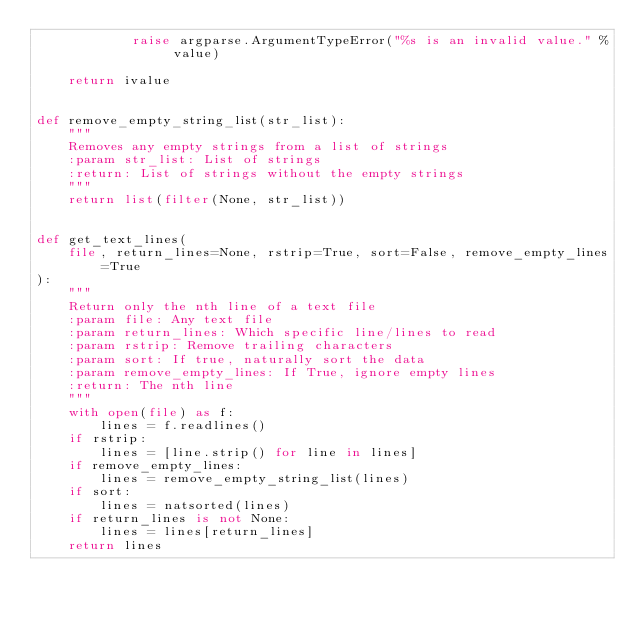<code> <loc_0><loc_0><loc_500><loc_500><_Python_>            raise argparse.ArgumentTypeError("%s is an invalid value." % value)

    return ivalue


def remove_empty_string_list(str_list):
    """
    Removes any empty strings from a list of strings
    :param str_list: List of strings
    :return: List of strings without the empty strings
    """
    return list(filter(None, str_list))


def get_text_lines(
    file, return_lines=None, rstrip=True, sort=False, remove_empty_lines=True
):
    """
    Return only the nth line of a text file
    :param file: Any text file
    :param return_lines: Which specific line/lines to read
    :param rstrip: Remove trailing characters
    :param sort: If true, naturally sort the data
    :param remove_empty_lines: If True, ignore empty lines
    :return: The nth line
    """
    with open(file) as f:
        lines = f.readlines()
    if rstrip:
        lines = [line.strip() for line in lines]
    if remove_empty_lines:
        lines = remove_empty_string_list(lines)
    if sort:
        lines = natsorted(lines)
    if return_lines is not None:
        lines = lines[return_lines]
    return lines
</code> 